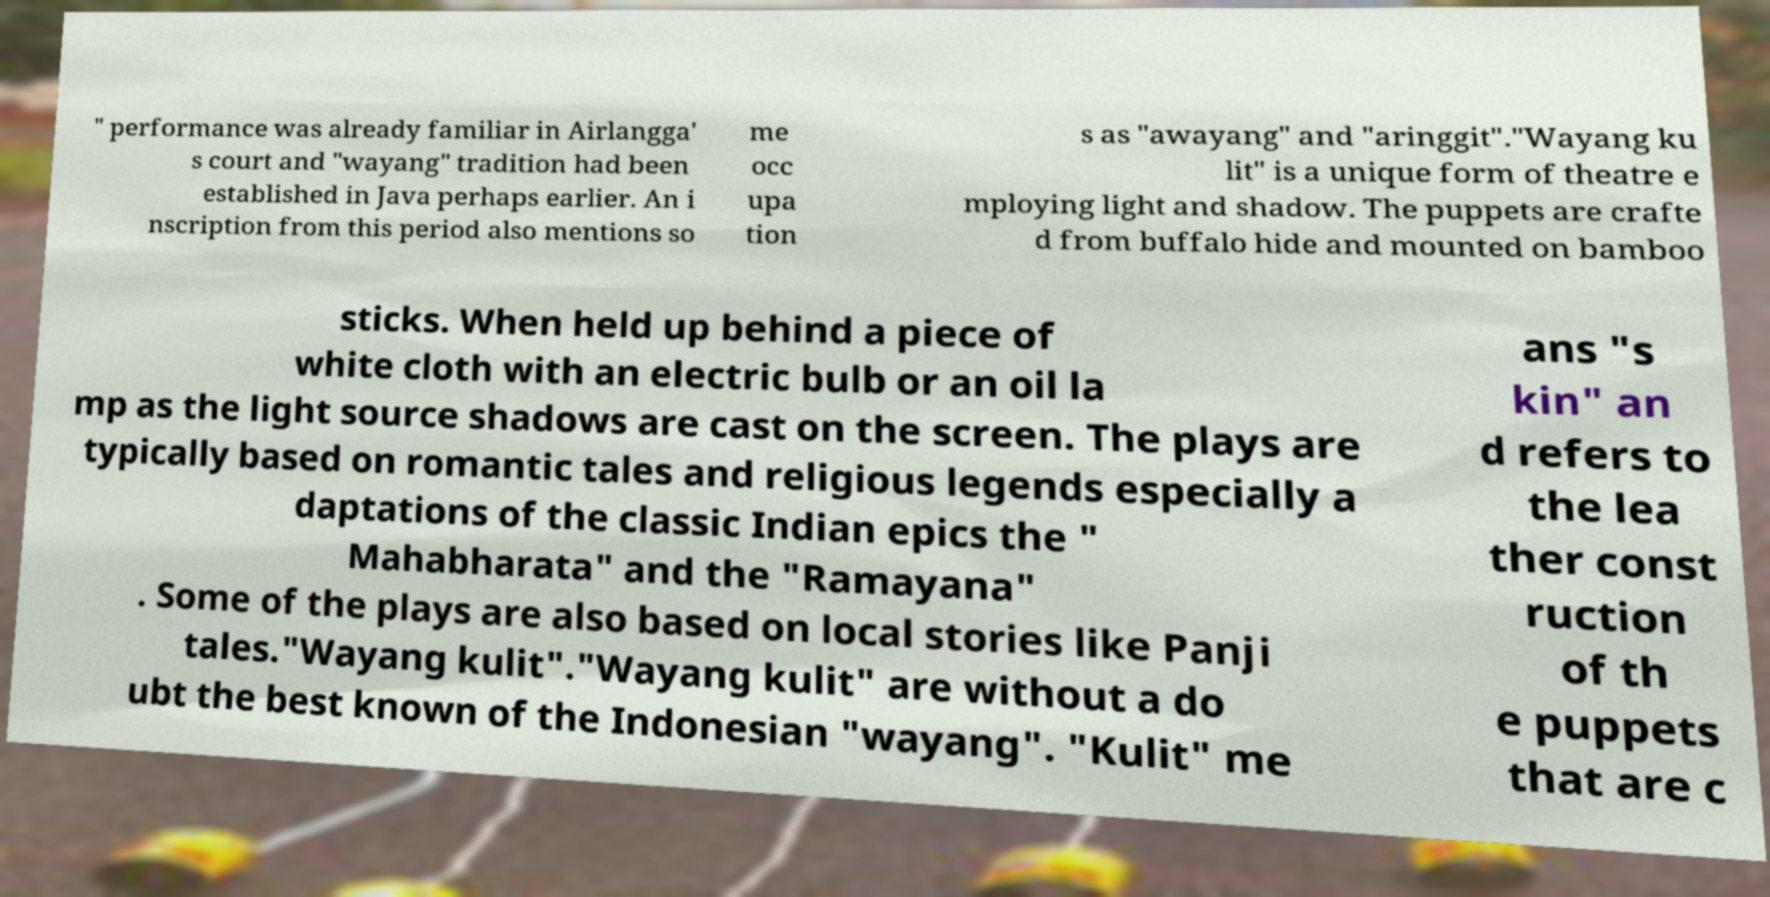Please read and relay the text visible in this image. What does it say? " performance was already familiar in Airlangga' s court and "wayang" tradition had been established in Java perhaps earlier. An i nscription from this period also mentions so me occ upa tion s as "awayang" and "aringgit"."Wayang ku lit" is a unique form of theatre e mploying light and shadow. The puppets are crafte d from buffalo hide and mounted on bamboo sticks. When held up behind a piece of white cloth with an electric bulb or an oil la mp as the light source shadows are cast on the screen. The plays are typically based on romantic tales and religious legends especially a daptations of the classic Indian epics the " Mahabharata" and the "Ramayana" . Some of the plays are also based on local stories like Panji tales."Wayang kulit"."Wayang kulit" are without a do ubt the best known of the Indonesian "wayang". "Kulit" me ans "s kin" an d refers to the lea ther const ruction of th e puppets that are c 